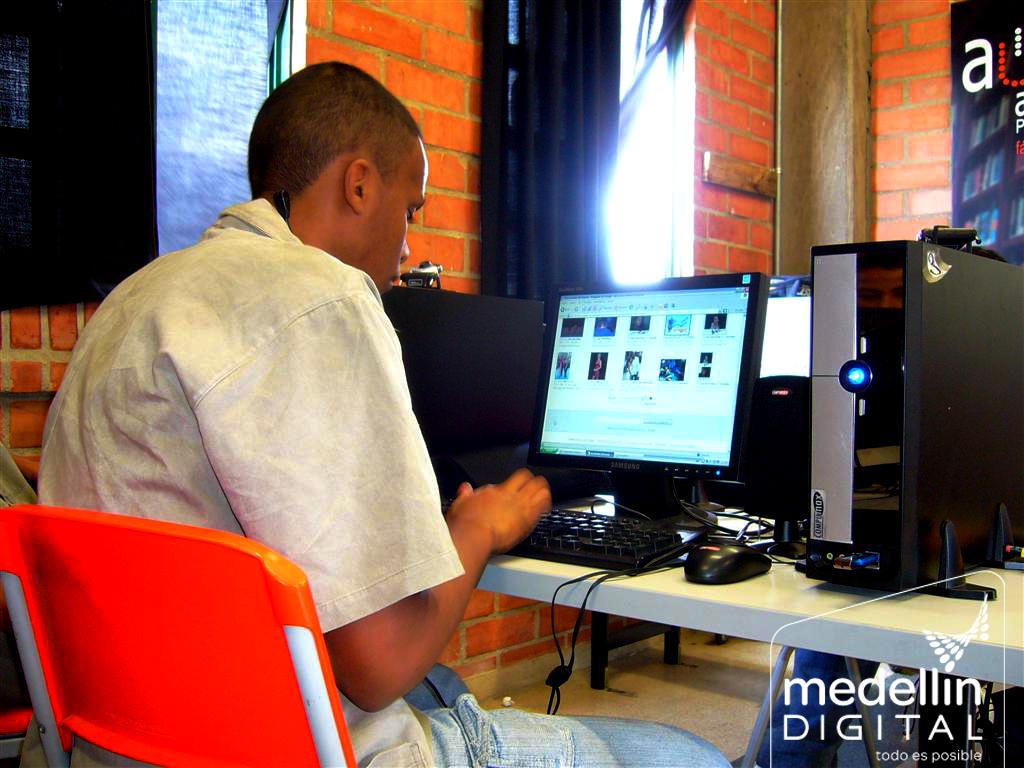What company is on this photo?
Ensure brevity in your answer.  Medellin digital. What letter is at the top right corner?
Offer a terse response. A. 